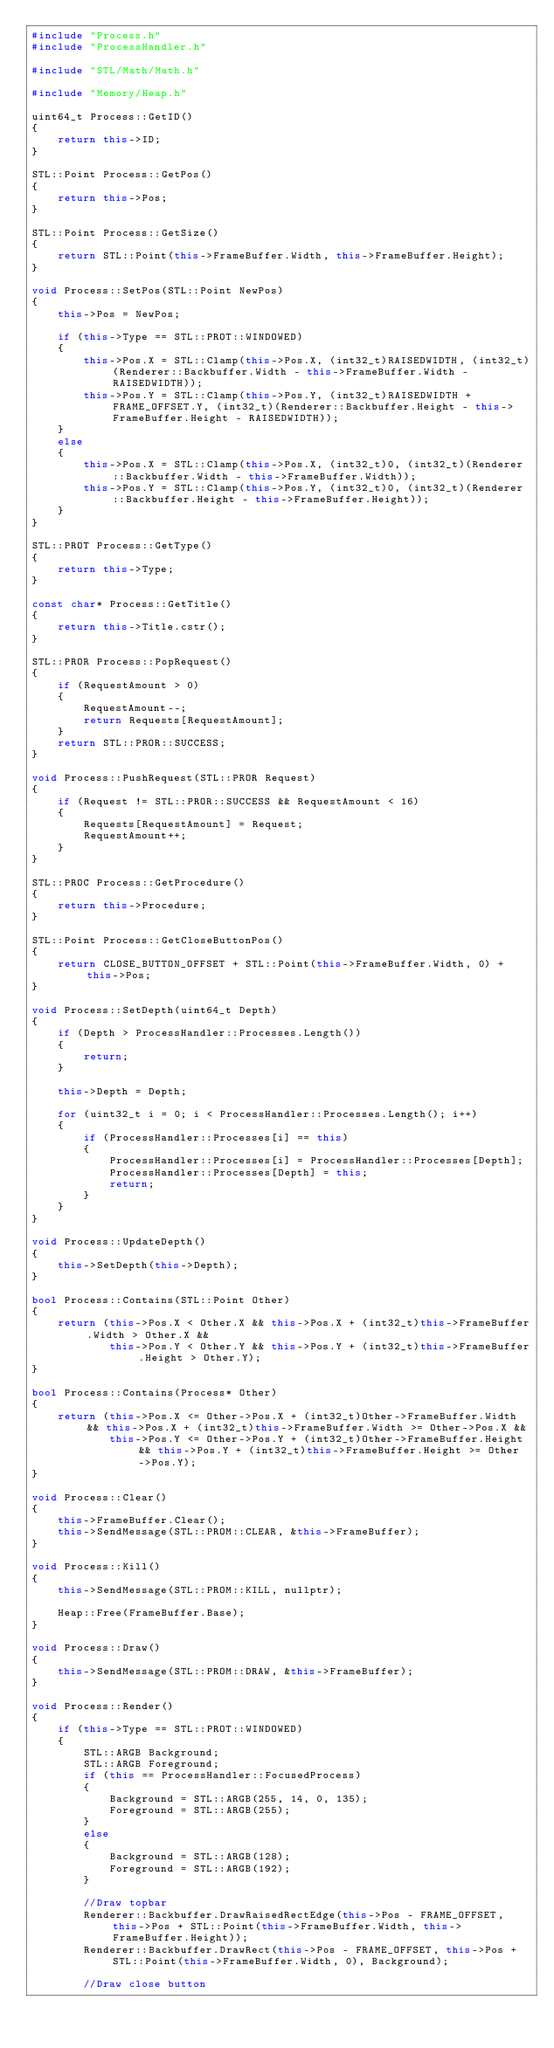<code> <loc_0><loc_0><loc_500><loc_500><_C++_>#include "Process.h"
#include "ProcessHandler.h"

#include "STL/Math/Math.h"

#include "Memory/Heap.h"

uint64_t Process::GetID()
{
    return this->ID;
}

STL::Point Process::GetPos()
{
    return this->Pos;
}

STL::Point Process::GetSize()
{
    return STL::Point(this->FrameBuffer.Width, this->FrameBuffer.Height);
}

void Process::SetPos(STL::Point NewPos)
{
    this->Pos = NewPos;

    if (this->Type == STL::PROT::WINDOWED)
    {
        this->Pos.X = STL::Clamp(this->Pos.X, (int32_t)RAISEDWIDTH, (int32_t)(Renderer::Backbuffer.Width - this->FrameBuffer.Width - RAISEDWIDTH));
        this->Pos.Y = STL::Clamp(this->Pos.Y, (int32_t)RAISEDWIDTH + FRAME_OFFSET.Y, (int32_t)(Renderer::Backbuffer.Height - this->FrameBuffer.Height - RAISEDWIDTH));        
    }
    else
    {
        this->Pos.X = STL::Clamp(this->Pos.X, (int32_t)0, (int32_t)(Renderer::Backbuffer.Width - this->FrameBuffer.Width));
        this->Pos.Y = STL::Clamp(this->Pos.Y, (int32_t)0, (int32_t)(Renderer::Backbuffer.Height - this->FrameBuffer.Height));        
    }
}

STL::PROT Process::GetType()
{
    return this->Type;
}

const char* Process::GetTitle()
{
    return this->Title.cstr();
}

STL::PROR Process::PopRequest()
{
    if (RequestAmount > 0)
    {        
        RequestAmount--;
        return Requests[RequestAmount];
    }   
    return STL::PROR::SUCCESS;
}

void Process::PushRequest(STL::PROR Request)
{
    if (Request != STL::PROR::SUCCESS && RequestAmount < 16)
    {
        Requests[RequestAmount] = Request;
        RequestAmount++;
    }
}

STL::PROC Process::GetProcedure()
{
    return this->Procedure;
}

STL::Point Process::GetCloseButtonPos()
{
    return CLOSE_BUTTON_OFFSET + STL::Point(this->FrameBuffer.Width, 0) + this->Pos; 
}

void Process::SetDepth(uint64_t Depth)
{
    if (Depth > ProcessHandler::Processes.Length())
    {
        return;
    }

    this->Depth = Depth;

    for (uint32_t i = 0; i < ProcessHandler::Processes.Length(); i++)
    {
        if (ProcessHandler::Processes[i] == this)
        {
            ProcessHandler::Processes[i] = ProcessHandler::Processes[Depth];
            ProcessHandler::Processes[Depth] = this;
            return;
        }
    }
}

void Process::UpdateDepth()
{
    this->SetDepth(this->Depth);
}

bool Process::Contains(STL::Point Other)
{
    return (this->Pos.X < Other.X && this->Pos.X + (int32_t)this->FrameBuffer.Width > Other.X &&
            this->Pos.Y < Other.Y && this->Pos.Y + (int32_t)this->FrameBuffer.Height > Other.Y);
}

bool Process::Contains(Process* Other)
{
    return (this->Pos.X <= Other->Pos.X + (int32_t)Other->FrameBuffer.Width && this->Pos.X + (int32_t)this->FrameBuffer.Width >= Other->Pos.X &&
            this->Pos.Y <= Other->Pos.Y + (int32_t)Other->FrameBuffer.Height && this->Pos.Y + (int32_t)this->FrameBuffer.Height >= Other->Pos.Y);
}

void Process::Clear()
{ 
    this->FrameBuffer.Clear();
    this->SendMessage(STL::PROM::CLEAR, &this->FrameBuffer);
}

void Process::Kill()
{
    this->SendMessage(STL::PROM::KILL, nullptr);

    Heap::Free(FrameBuffer.Base);
}

void Process::Draw()
{
    this->SendMessage(STL::PROM::DRAW, &this->FrameBuffer);
}

void Process::Render()
{
    if (this->Type == STL::PROT::WINDOWED)
    {         
        STL::ARGB Background;
        STL::ARGB Foreground;
        if (this == ProcessHandler::FocusedProcess)
        {
            Background = STL::ARGB(255, 14, 0, 135);            
            Foreground = STL::ARGB(255);
        }
        else
        {
            Background = STL::ARGB(128);            
            Foreground = STL::ARGB(192);            
        }

        //Draw topbar
        Renderer::Backbuffer.DrawRaisedRectEdge(this->Pos - FRAME_OFFSET, this->Pos + STL::Point(this->FrameBuffer.Width, this->FrameBuffer.Height));
        Renderer::Backbuffer.DrawRect(this->Pos - FRAME_OFFSET, this->Pos + STL::Point(this->FrameBuffer.Width, 0), Background);

        //Draw close button</code> 